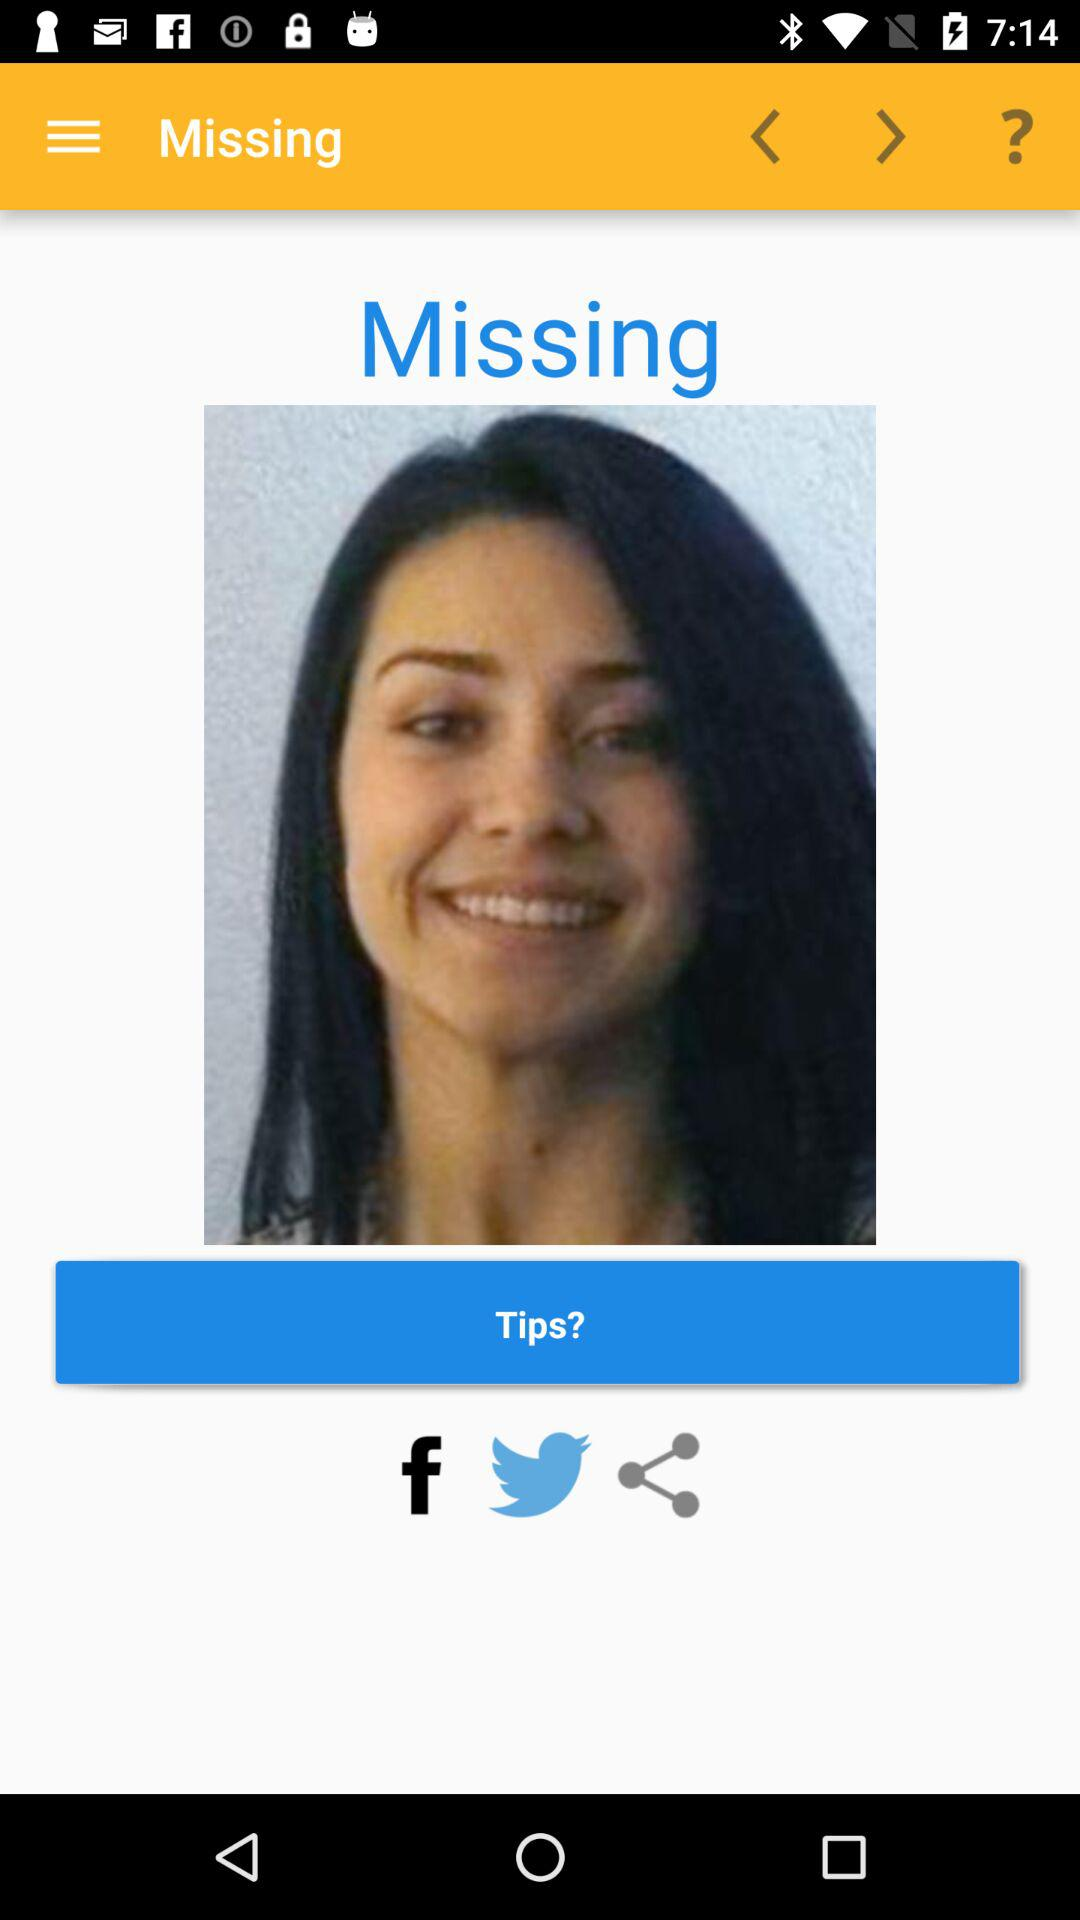What are the sharing options? The sharing options are "Facebook" and "Twitter". 